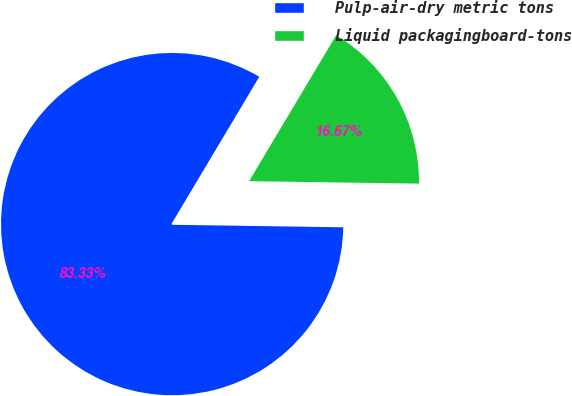Convert chart. <chart><loc_0><loc_0><loc_500><loc_500><pie_chart><fcel>Pulp-air-dry metric tons<fcel>Liquid packagingboard-tons<nl><fcel>83.33%<fcel>16.67%<nl></chart> 